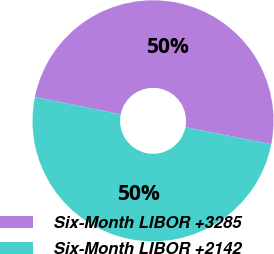Convert chart to OTSL. <chart><loc_0><loc_0><loc_500><loc_500><pie_chart><fcel>Six-Month LIBOR +3285<fcel>Six-Month LIBOR +2142<nl><fcel>49.95%<fcel>50.05%<nl></chart> 